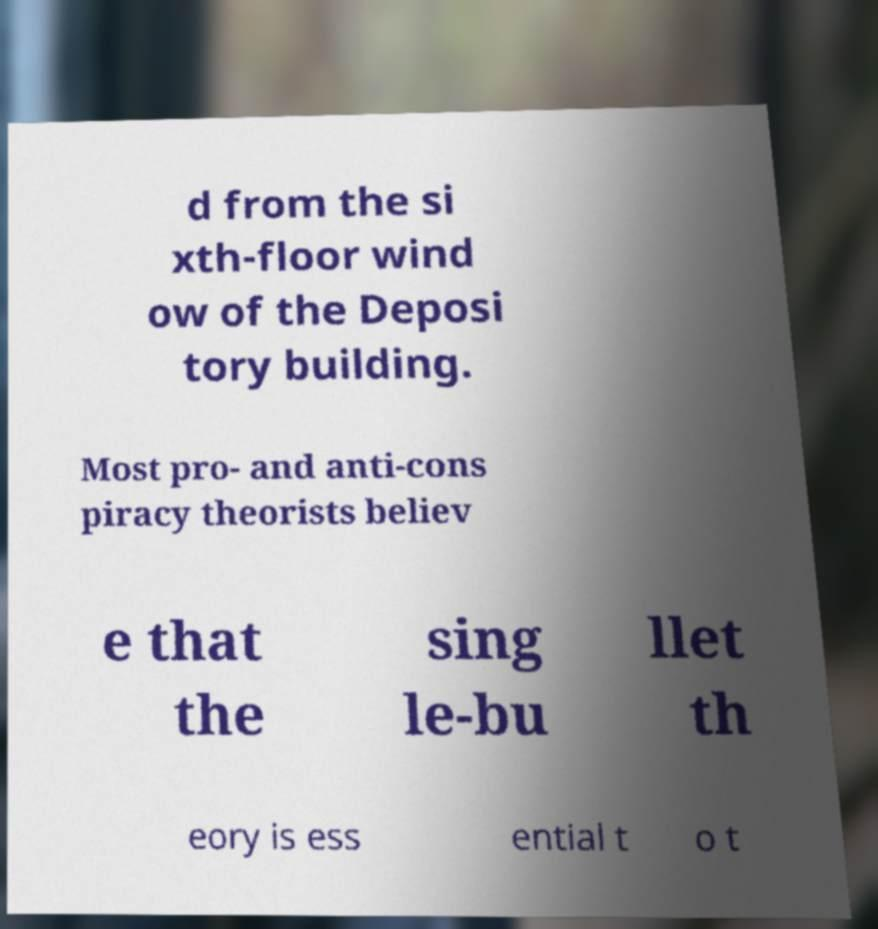There's text embedded in this image that I need extracted. Can you transcribe it verbatim? d from the si xth-floor wind ow of the Deposi tory building. Most pro- and anti-cons piracy theorists believ e that the sing le-bu llet th eory is ess ential t o t 